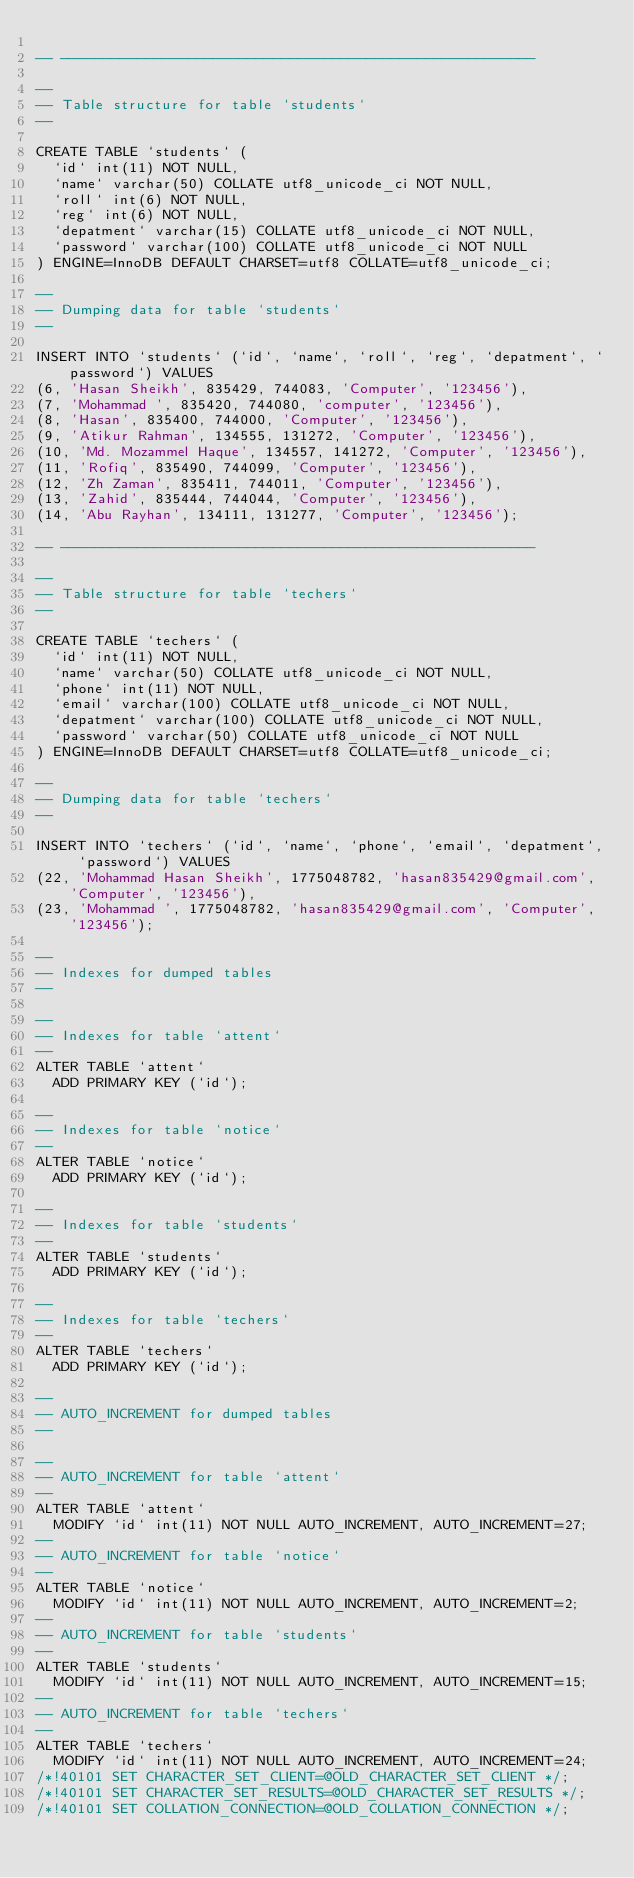Convert code to text. <code><loc_0><loc_0><loc_500><loc_500><_SQL_>
-- --------------------------------------------------------

--
-- Table structure for table `students`
--

CREATE TABLE `students` (
  `id` int(11) NOT NULL,
  `name` varchar(50) COLLATE utf8_unicode_ci NOT NULL,
  `roll` int(6) NOT NULL,
  `reg` int(6) NOT NULL,
  `depatment` varchar(15) COLLATE utf8_unicode_ci NOT NULL,
  `password` varchar(100) COLLATE utf8_unicode_ci NOT NULL
) ENGINE=InnoDB DEFAULT CHARSET=utf8 COLLATE=utf8_unicode_ci;

--
-- Dumping data for table `students`
--

INSERT INTO `students` (`id`, `name`, `roll`, `reg`, `depatment`, `password`) VALUES
(6, 'Hasan Sheikh', 835429, 744083, 'Computer', '123456'),
(7, 'Mohammad ', 835420, 744080, 'computer', '123456'),
(8, 'Hasan', 835400, 744000, 'Computer', '123456'),
(9, 'Atikur Rahman', 134555, 131272, 'Computer', '123456'),
(10, 'Md. Mozammel Haque', 134557, 141272, 'Computer', '123456'),
(11, 'Rofiq', 835490, 744099, 'Computer', '123456'),
(12, 'Zh Zaman', 835411, 744011, 'Computer', '123456'),
(13, 'Zahid', 835444, 744044, 'Computer', '123456'),
(14, 'Abu Rayhan', 134111, 131277, 'Computer', '123456');

-- --------------------------------------------------------

--
-- Table structure for table `techers`
--

CREATE TABLE `techers` (
  `id` int(11) NOT NULL,
  `name` varchar(50) COLLATE utf8_unicode_ci NOT NULL,
  `phone` int(11) NOT NULL,
  `email` varchar(100) COLLATE utf8_unicode_ci NOT NULL,
  `depatment` varchar(100) COLLATE utf8_unicode_ci NOT NULL,
  `password` varchar(50) COLLATE utf8_unicode_ci NOT NULL
) ENGINE=InnoDB DEFAULT CHARSET=utf8 COLLATE=utf8_unicode_ci;

--
-- Dumping data for table `techers`
--

INSERT INTO `techers` (`id`, `name`, `phone`, `email`, `depatment`, `password`) VALUES
(22, 'Mohammad Hasan Sheikh', 1775048782, 'hasan835429@gmail.com', 'Computer', '123456'),
(23, 'Mohammad ', 1775048782, 'hasan835429@gmail.com', 'Computer', '123456');

--
-- Indexes for dumped tables
--

--
-- Indexes for table `attent`
--
ALTER TABLE `attent`
  ADD PRIMARY KEY (`id`);

--
-- Indexes for table `notice`
--
ALTER TABLE `notice`
  ADD PRIMARY KEY (`id`);

--
-- Indexes for table `students`
--
ALTER TABLE `students`
  ADD PRIMARY KEY (`id`);

--
-- Indexes for table `techers`
--
ALTER TABLE `techers`
  ADD PRIMARY KEY (`id`);

--
-- AUTO_INCREMENT for dumped tables
--

--
-- AUTO_INCREMENT for table `attent`
--
ALTER TABLE `attent`
  MODIFY `id` int(11) NOT NULL AUTO_INCREMENT, AUTO_INCREMENT=27;
--
-- AUTO_INCREMENT for table `notice`
--
ALTER TABLE `notice`
  MODIFY `id` int(11) NOT NULL AUTO_INCREMENT, AUTO_INCREMENT=2;
--
-- AUTO_INCREMENT for table `students`
--
ALTER TABLE `students`
  MODIFY `id` int(11) NOT NULL AUTO_INCREMENT, AUTO_INCREMENT=15;
--
-- AUTO_INCREMENT for table `techers`
--
ALTER TABLE `techers`
  MODIFY `id` int(11) NOT NULL AUTO_INCREMENT, AUTO_INCREMENT=24;
/*!40101 SET CHARACTER_SET_CLIENT=@OLD_CHARACTER_SET_CLIENT */;
/*!40101 SET CHARACTER_SET_RESULTS=@OLD_CHARACTER_SET_RESULTS */;
/*!40101 SET COLLATION_CONNECTION=@OLD_COLLATION_CONNECTION */;
</code> 